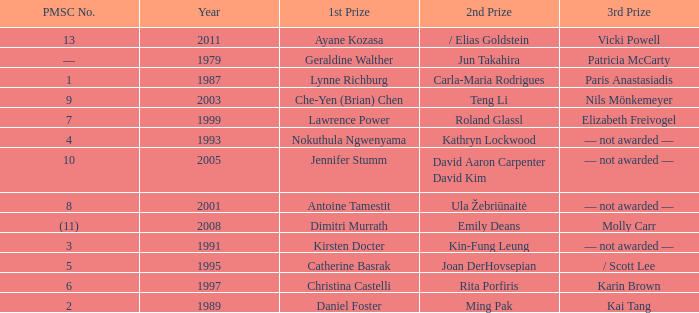What is the earliest year in which the 1st price went to Che-Yen (Brian) Chen? 2003.0. 